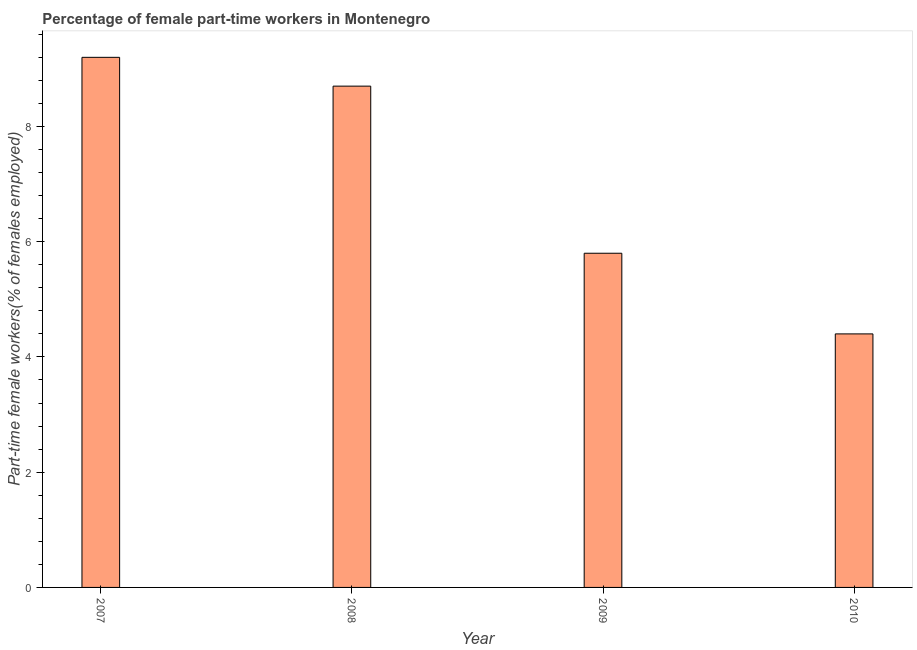Does the graph contain grids?
Your answer should be compact. No. What is the title of the graph?
Provide a short and direct response. Percentage of female part-time workers in Montenegro. What is the label or title of the Y-axis?
Your answer should be very brief. Part-time female workers(% of females employed). What is the percentage of part-time female workers in 2009?
Offer a terse response. 5.8. Across all years, what is the maximum percentage of part-time female workers?
Keep it short and to the point. 9.2. Across all years, what is the minimum percentage of part-time female workers?
Your answer should be very brief. 4.4. In which year was the percentage of part-time female workers maximum?
Offer a very short reply. 2007. What is the sum of the percentage of part-time female workers?
Your response must be concise. 28.1. What is the average percentage of part-time female workers per year?
Keep it short and to the point. 7.03. What is the median percentage of part-time female workers?
Offer a very short reply. 7.25. In how many years, is the percentage of part-time female workers greater than 6 %?
Your answer should be compact. 2. Is the percentage of part-time female workers in 2007 less than that in 2010?
Offer a terse response. No. What is the difference between the highest and the second highest percentage of part-time female workers?
Provide a short and direct response. 0.5. Is the sum of the percentage of part-time female workers in 2007 and 2008 greater than the maximum percentage of part-time female workers across all years?
Your response must be concise. Yes. How many bars are there?
Your response must be concise. 4. What is the Part-time female workers(% of females employed) of 2007?
Your answer should be compact. 9.2. What is the Part-time female workers(% of females employed) of 2008?
Give a very brief answer. 8.7. What is the Part-time female workers(% of females employed) of 2009?
Make the answer very short. 5.8. What is the Part-time female workers(% of females employed) in 2010?
Make the answer very short. 4.4. What is the difference between the Part-time female workers(% of females employed) in 2007 and 2008?
Keep it short and to the point. 0.5. What is the difference between the Part-time female workers(% of females employed) in 2008 and 2009?
Provide a short and direct response. 2.9. What is the difference between the Part-time female workers(% of females employed) in 2008 and 2010?
Provide a short and direct response. 4.3. What is the difference between the Part-time female workers(% of females employed) in 2009 and 2010?
Your response must be concise. 1.4. What is the ratio of the Part-time female workers(% of females employed) in 2007 to that in 2008?
Provide a short and direct response. 1.06. What is the ratio of the Part-time female workers(% of females employed) in 2007 to that in 2009?
Ensure brevity in your answer.  1.59. What is the ratio of the Part-time female workers(% of females employed) in 2007 to that in 2010?
Provide a short and direct response. 2.09. What is the ratio of the Part-time female workers(% of females employed) in 2008 to that in 2009?
Ensure brevity in your answer.  1.5. What is the ratio of the Part-time female workers(% of females employed) in 2008 to that in 2010?
Your answer should be compact. 1.98. What is the ratio of the Part-time female workers(% of females employed) in 2009 to that in 2010?
Offer a very short reply. 1.32. 